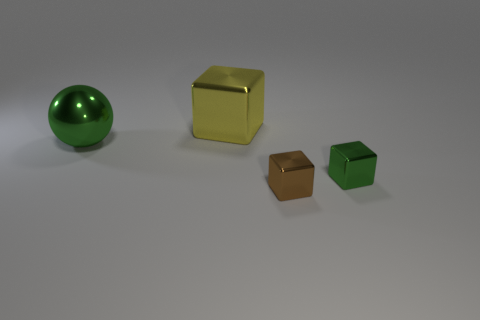What number of cubes are either brown metal objects or big yellow shiny objects? The image displays a total of three cubes, none of which are brown metal. There is, however, one big yellow shiny cube visible among them. So, the correct answer to the question is one, as only the large yellow cube fits the criteria described. 